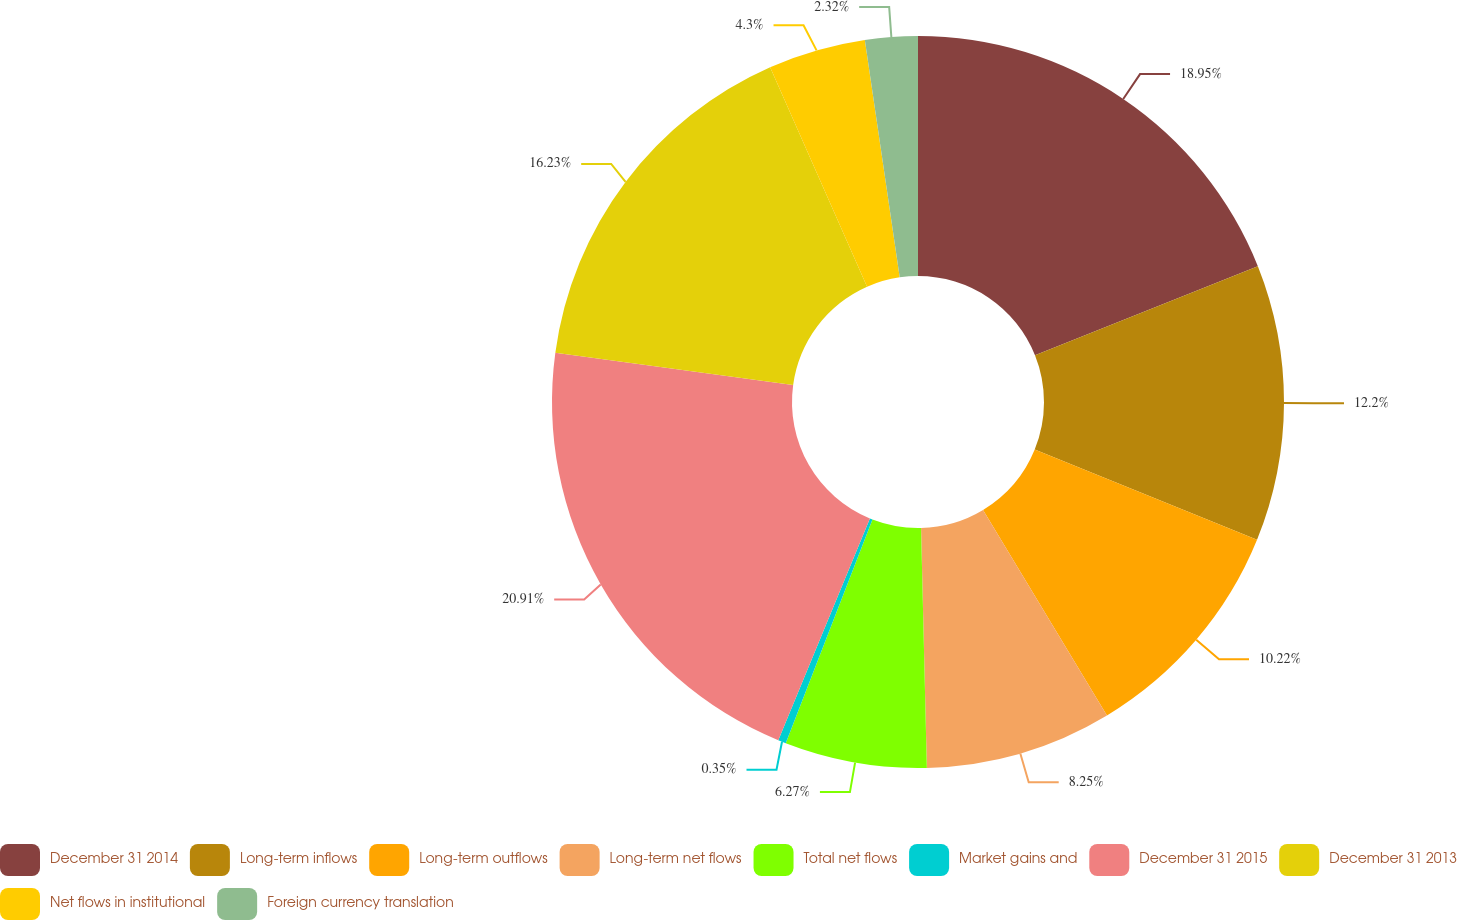Convert chart to OTSL. <chart><loc_0><loc_0><loc_500><loc_500><pie_chart><fcel>December 31 2014<fcel>Long-term inflows<fcel>Long-term outflows<fcel>Long-term net flows<fcel>Total net flows<fcel>Market gains and<fcel>December 31 2015<fcel>December 31 2013<fcel>Net flows in institutional<fcel>Foreign currency translation<nl><fcel>18.95%<fcel>12.2%<fcel>10.22%<fcel>8.25%<fcel>6.27%<fcel>0.35%<fcel>20.92%<fcel>16.23%<fcel>4.3%<fcel>2.32%<nl></chart> 